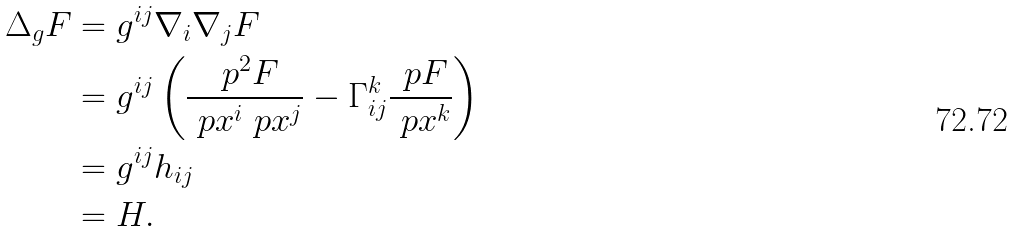<formula> <loc_0><loc_0><loc_500><loc_500>\Delta _ { g } F & = g ^ { i j } \nabla _ { i } \nabla _ { j } F \\ & = g ^ { i j } \left ( \frac { \ p ^ { 2 } F } { \ p x ^ { i } \ p x ^ { j } } - \Gamma _ { i j } ^ { k } \frac { \ p F } { \ p x ^ { k } } \right ) \\ & = g ^ { i j } h _ { i j } \\ & = H .</formula> 